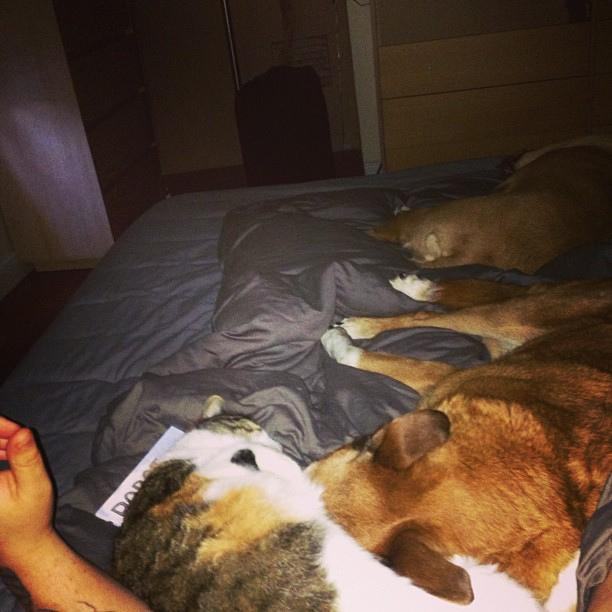The cat is cozying up to what animal? Please explain your reasoning. dog. There is a dog sleeping to the right of the cat. 